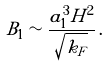Convert formula to latex. <formula><loc_0><loc_0><loc_500><loc_500>B _ { 1 } \sim \frac { a _ { 1 } ^ { 3 } H ^ { 2 } } { \sqrt { k _ { F } } } \, .</formula> 